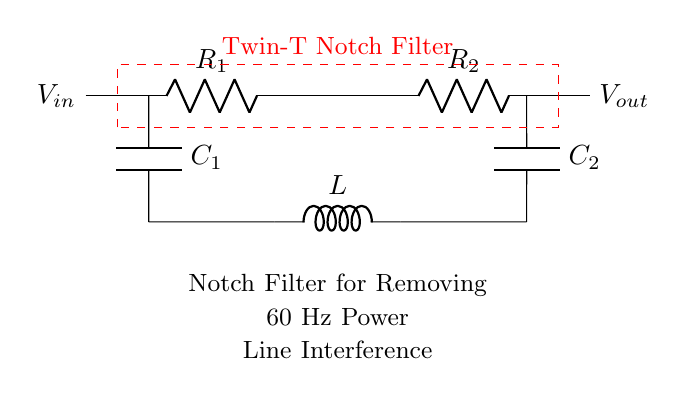What type of filter is represented in this circuit? The circuit is a Twin-T Notch Filter, which is designed specifically to remove a narrow band of frequencies, in this case, the 60 Hz power line interference. The label within the red dashed rectangle clearly indicates the type of filter used.
Answer: Twin-T Notch Filter What frequencies does this filter target? The circuit diagram is designed to target 60 Hz, which is the frequency of the power line interference commonly found in medical equipment. This is specified in the labeling within the circuit.
Answer: 60 Hz How many resistors are present in the circuit? The diagram shows two resistors labeled as R1 and R2. Counting the components gives a total of two resistors.
Answer: 2 What is the role of the capacitor in the filter? Capacitors in this configuration store energy in the electric field and react to changes in voltage. In the context of this notch filter, they help define the frequency response and create the notching effect by working in conjunction with the inductance.
Answer: Energy storage What is the output voltage connection in this circuit? The output voltage, labeled as Vout, is connected directly to the right of the last capacitor (C2) in the circuit. The labeling on the right indicates where the voltage output can be measured.
Answer: Vout How does the inductor contribute to the notch filter's function? The inductor (L) contributes by introducing inductive reactance at certain frequencies, in conjunction with the capacitors, to create a filter that provides a notch for specific frequencies like the 60 Hz interference. This helps in attenuating unwanted signals while allowing others to pass through.
Answer: Attenuates unwanted signals 